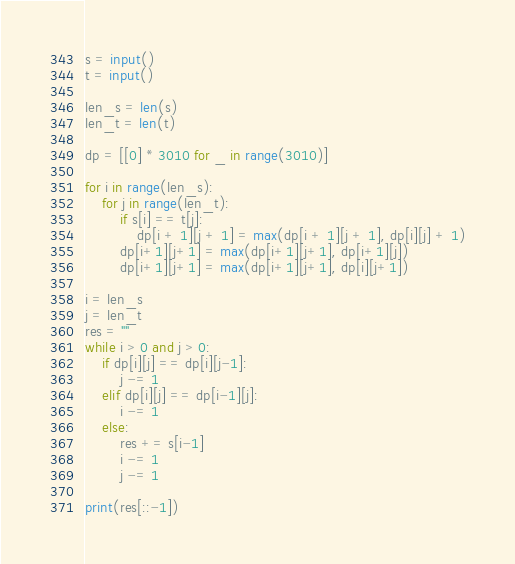Convert code to text. <code><loc_0><loc_0><loc_500><loc_500><_Python_>s = input()
t = input()

len_s = len(s)
len_t = len(t)

dp = [[0] * 3010 for _ in range(3010)]

for i in range(len_s):
    for j in range(len_t):
        if s[i] == t[j]:
            dp[i + 1][j + 1] = max(dp[i + 1][j + 1], dp[i][j] + 1)
        dp[i+1][j+1] = max(dp[i+1][j+1], dp[i+1][j])
        dp[i+1][j+1] = max(dp[i+1][j+1], dp[i][j+1])

i = len_s
j = len_t
res = ""
while i > 0 and j > 0:
    if dp[i][j] == dp[i][j-1]:
        j -= 1
    elif dp[i][j] == dp[i-1][j]:
        i -= 1
    else:
        res += s[i-1]
        i -= 1
        j -= 1

print(res[::-1])
</code> 